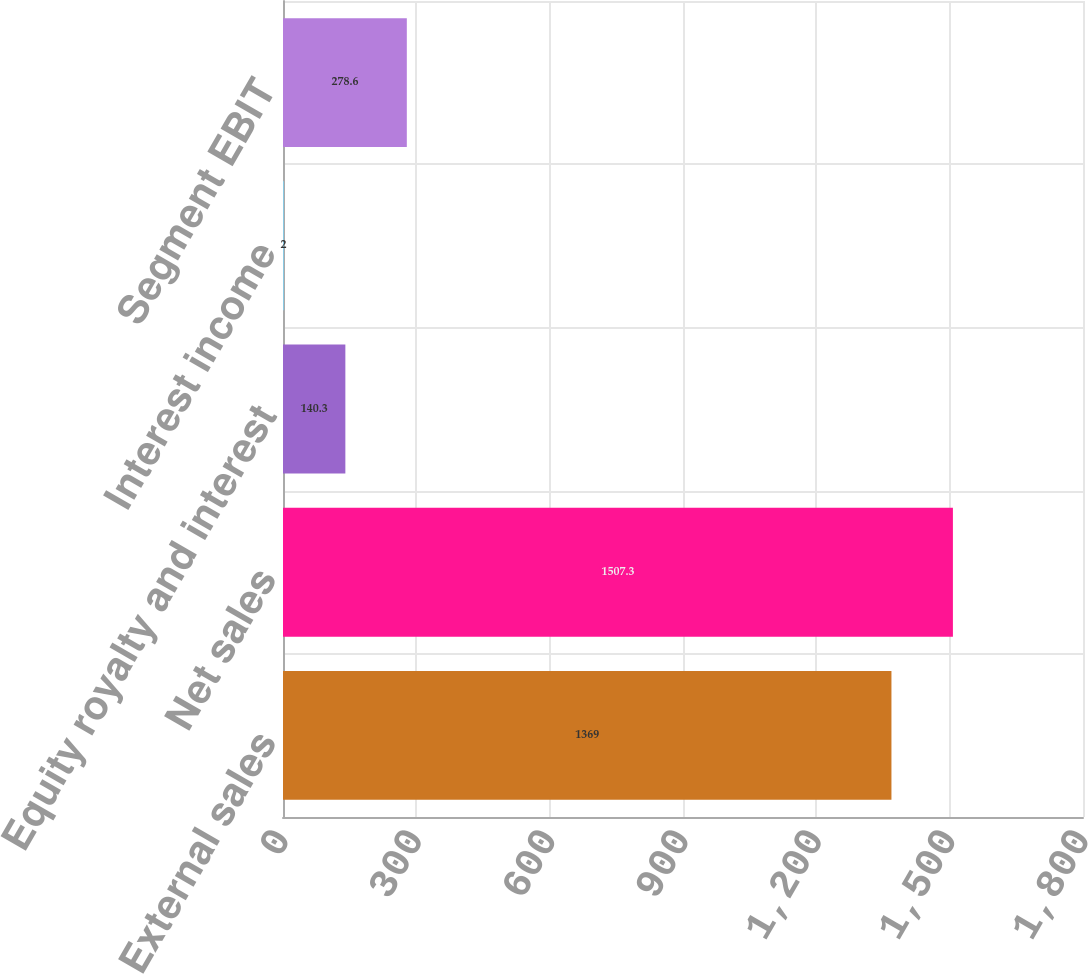<chart> <loc_0><loc_0><loc_500><loc_500><bar_chart><fcel>External sales<fcel>Net sales<fcel>Equity royalty and interest<fcel>Interest income<fcel>Segment EBIT<nl><fcel>1369<fcel>1507.3<fcel>140.3<fcel>2<fcel>278.6<nl></chart> 